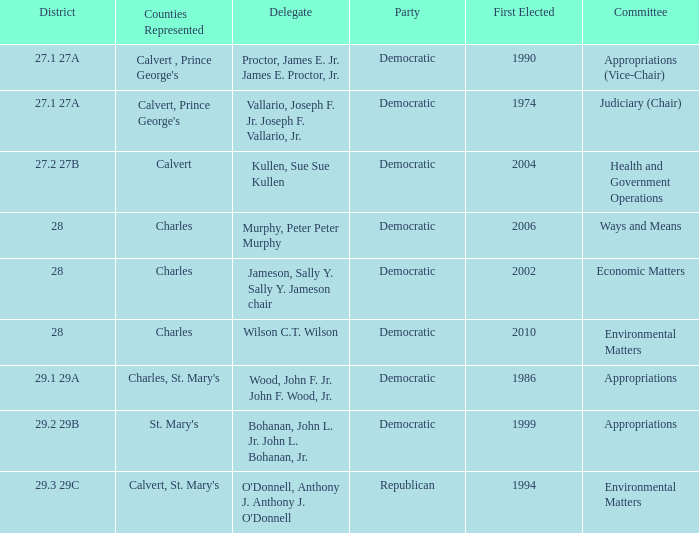What is the democratic district that initially elected more than 2006? 28.0. 